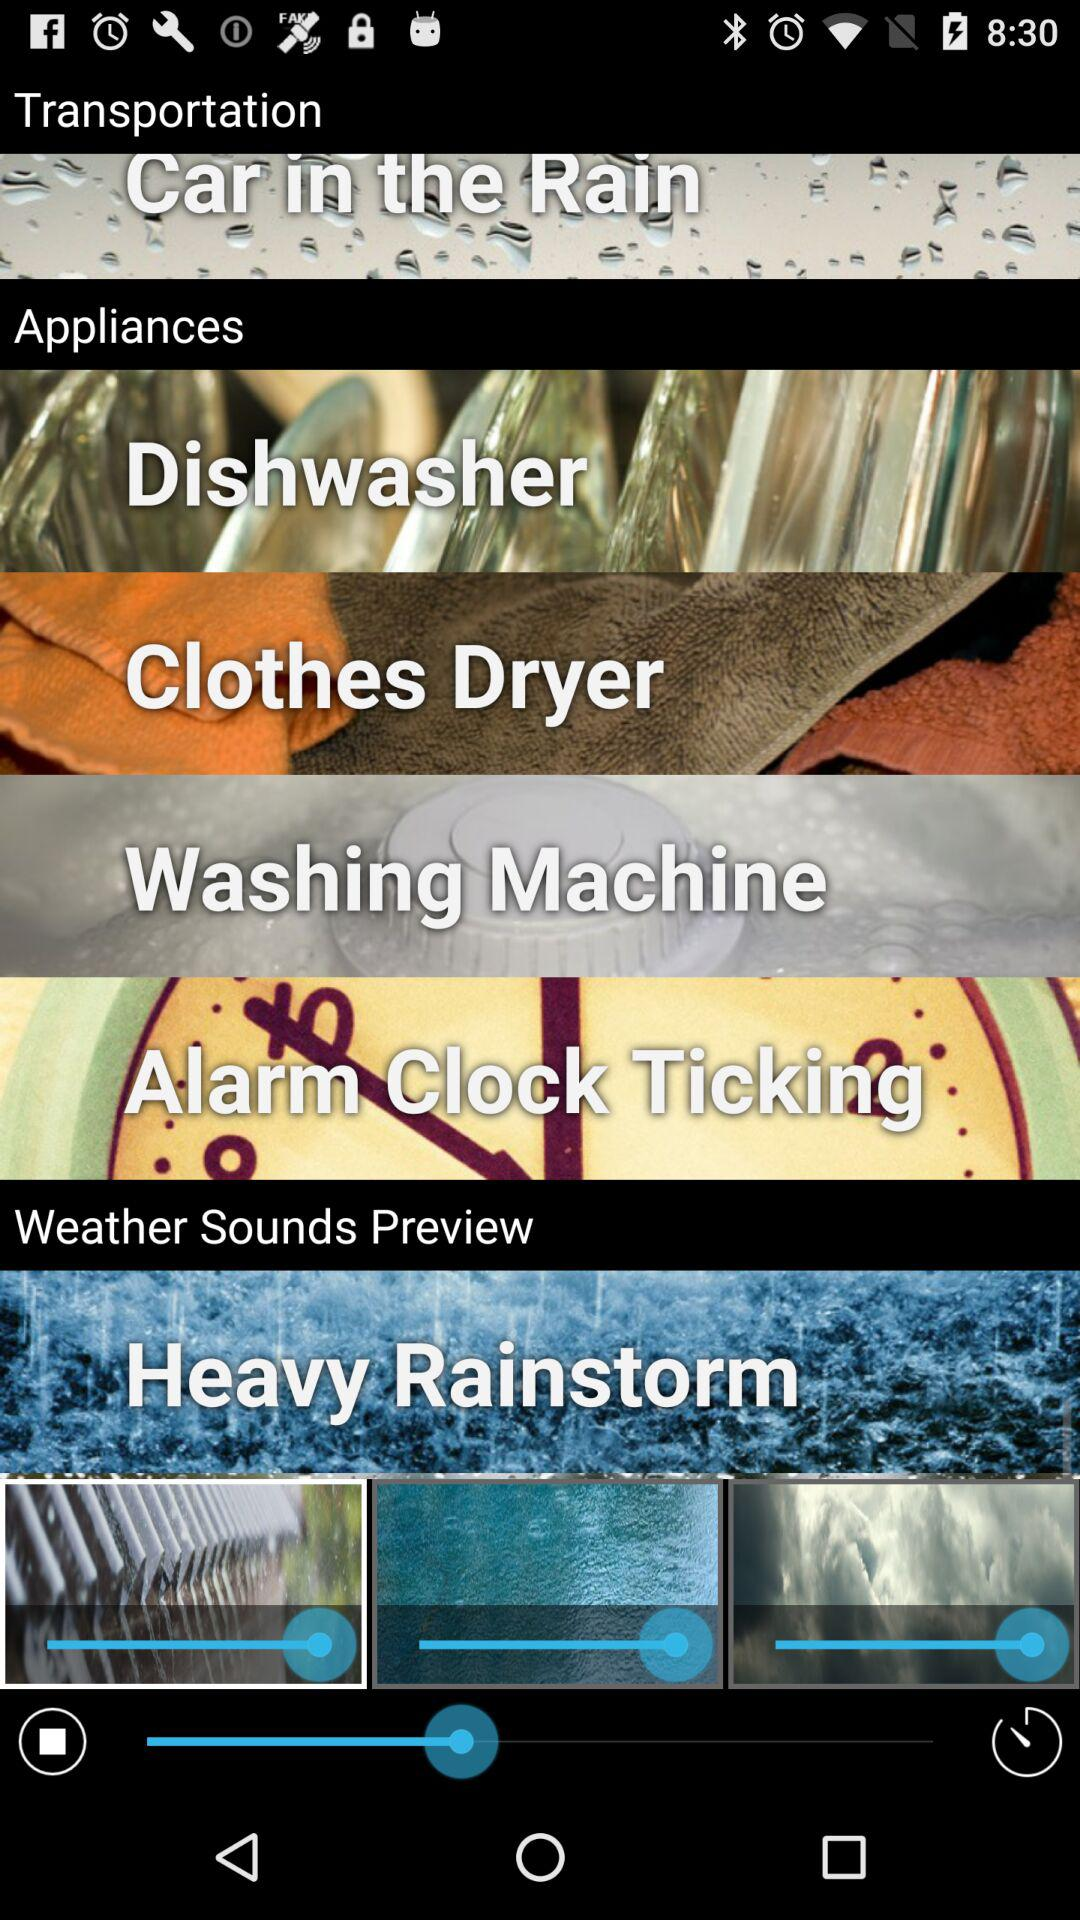Which option is in the "Weather Sounds Preview" setting? The option is "Heavy Rainstorm". 